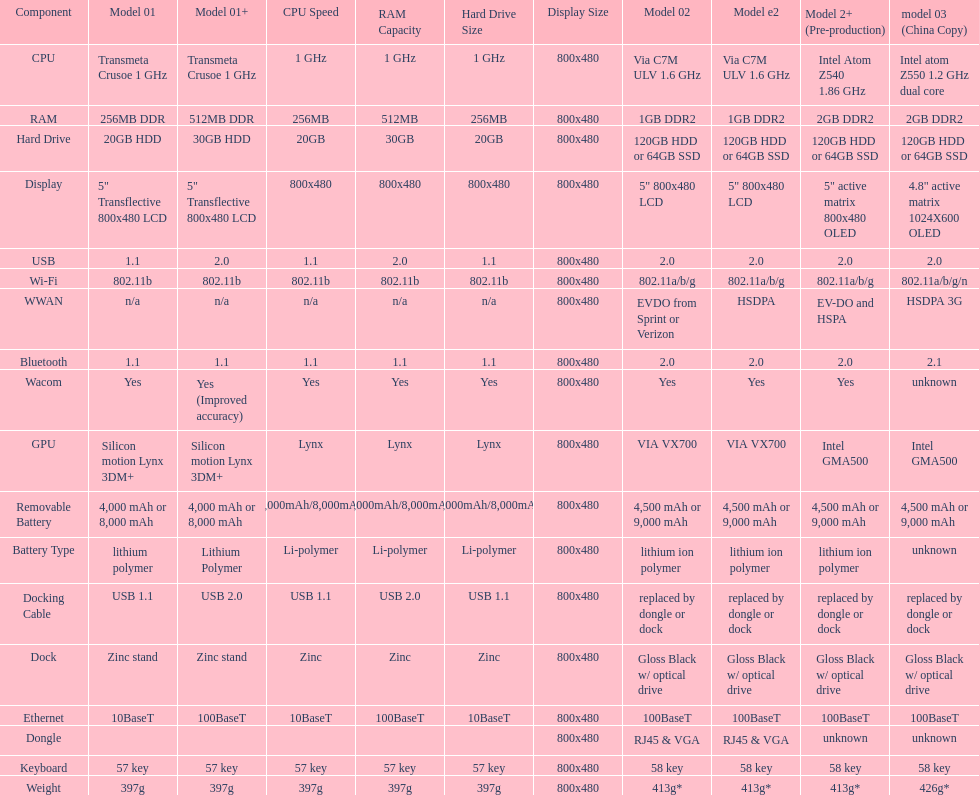Which model provides a larger hard drive: model 01 or model 02? Model 02. 